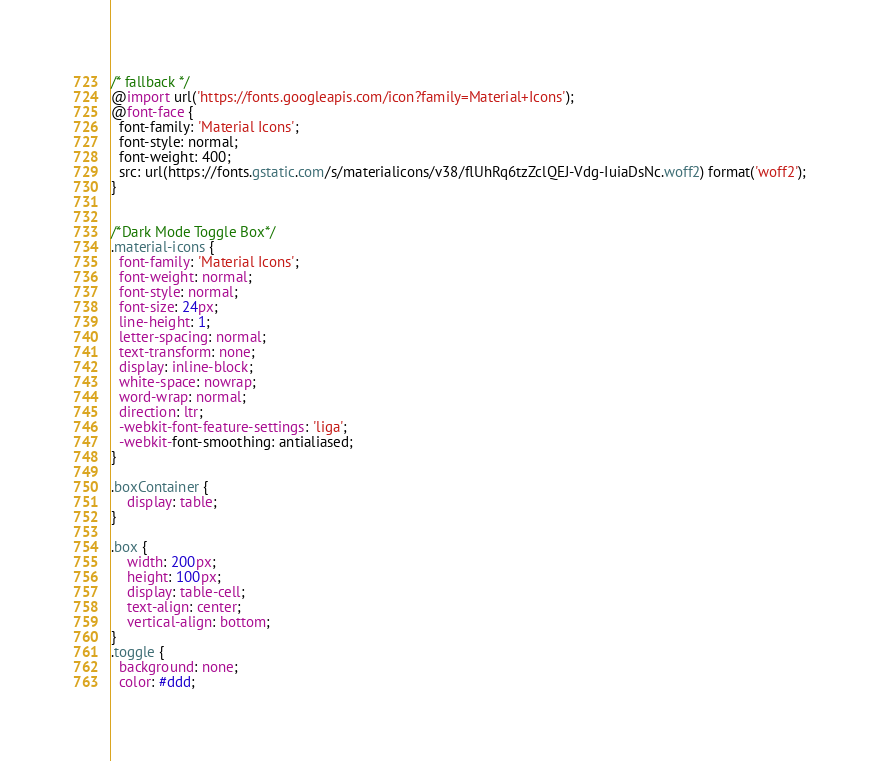<code> <loc_0><loc_0><loc_500><loc_500><_CSS_>/* fallback */
@import url('https://fonts.googleapis.com/icon?family=Material+Icons');
@font-face {
  font-family: 'Material Icons';
  font-style: normal;
  font-weight: 400;
  src: url(https://fonts.gstatic.com/s/materialicons/v38/flUhRq6tzZclQEJ-Vdg-IuiaDsNc.woff2) format('woff2');
}


/*Dark Mode Toggle Box*/
.material-icons {
  font-family: 'Material Icons';
  font-weight: normal;
  font-style: normal;
  font-size: 24px;
  line-height: 1;
  letter-spacing: normal;
  text-transform: none;
  display: inline-block;
  white-space: nowrap;
  word-wrap: normal;
  direction: ltr;
  -webkit-font-feature-settings: 'liga';
  -webkit-font-smoothing: antialiased;
}

.boxContainer {
    display: table;
}

.box {
    width: 200px;
    height: 100px;
    display: table-cell;
    text-align: center;
    vertical-align: bottom;
}
.toggle {
  background: none;
  color: #ddd;</code> 